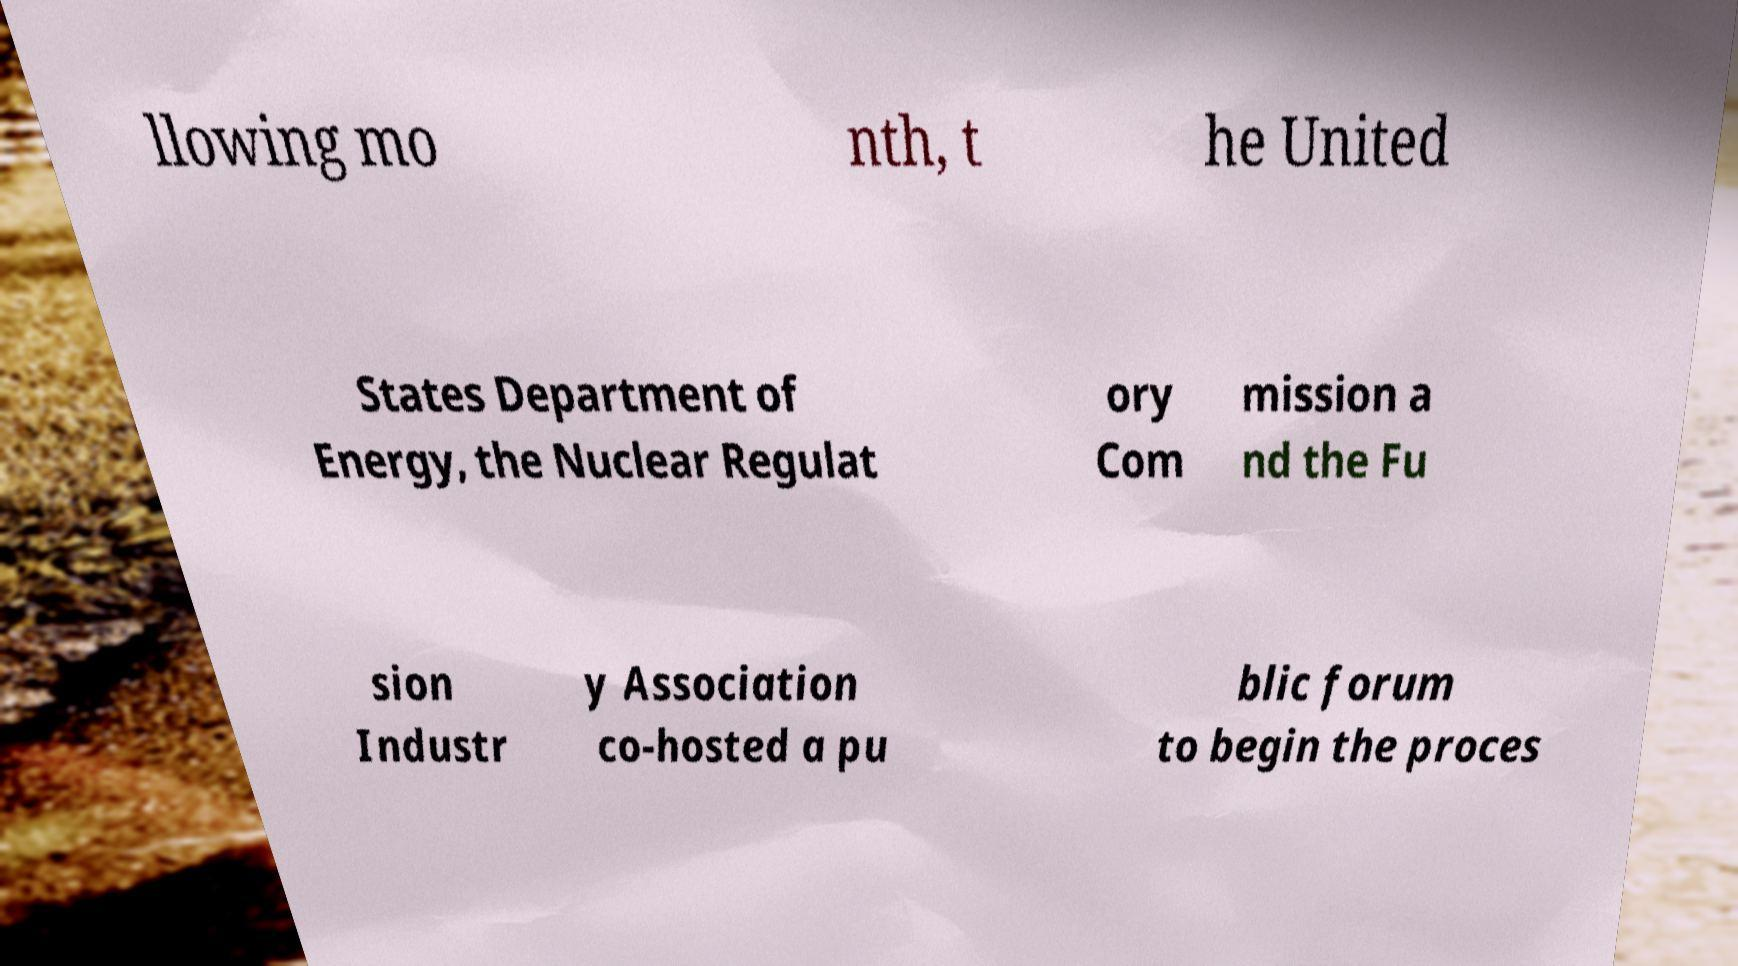Please identify and transcribe the text found in this image. llowing mo nth, t he United States Department of Energy, the Nuclear Regulat ory Com mission a nd the Fu sion Industr y Association co-hosted a pu blic forum to begin the proces 